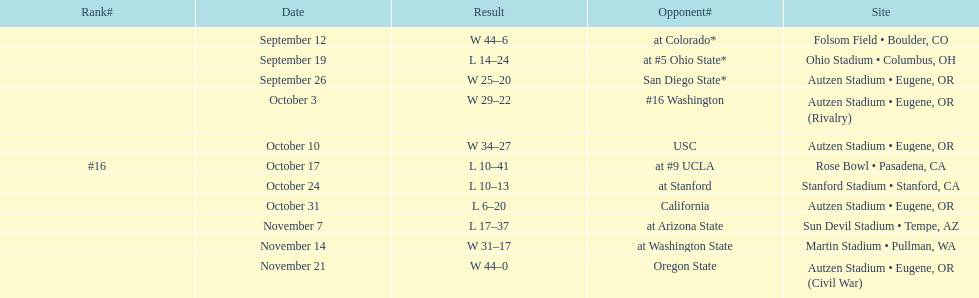Were the results of the game of november 14 above or below the results of the october 17 game? Above. 